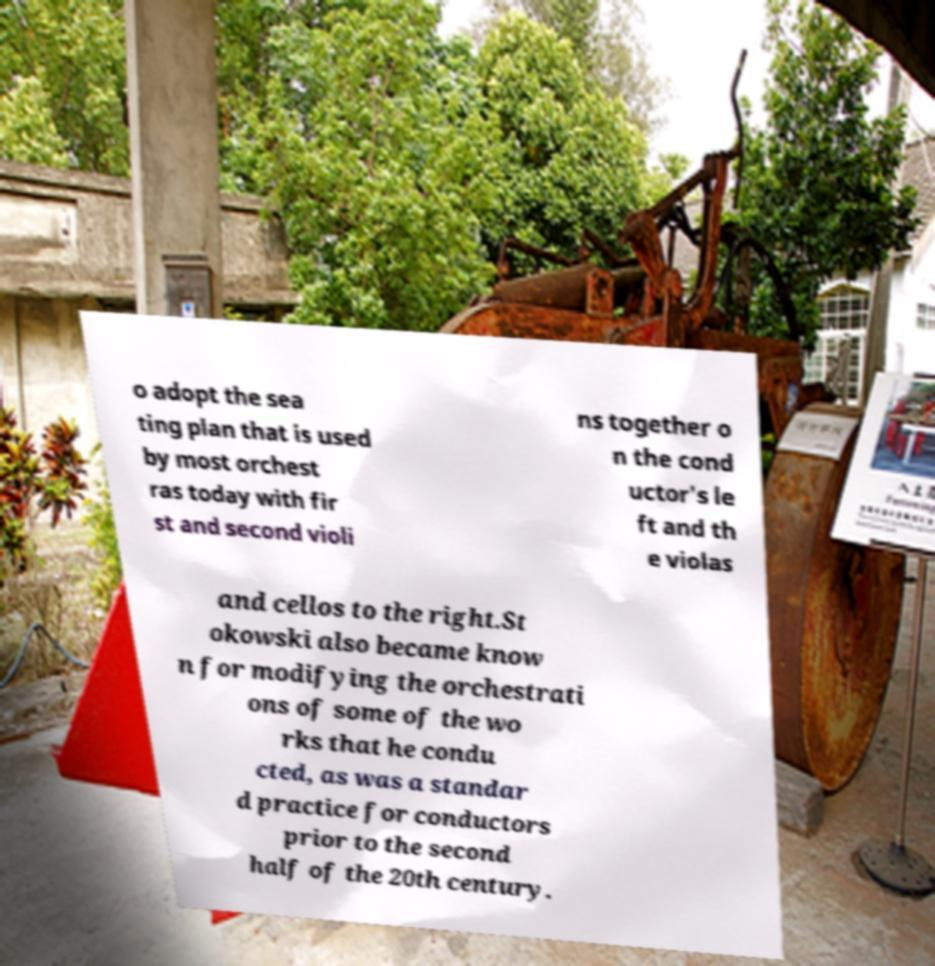What messages or text are displayed in this image? I need them in a readable, typed format. o adopt the sea ting plan that is used by most orchest ras today with fir st and second violi ns together o n the cond uctor's le ft and th e violas and cellos to the right.St okowski also became know n for modifying the orchestrati ons of some of the wo rks that he condu cted, as was a standar d practice for conductors prior to the second half of the 20th century. 